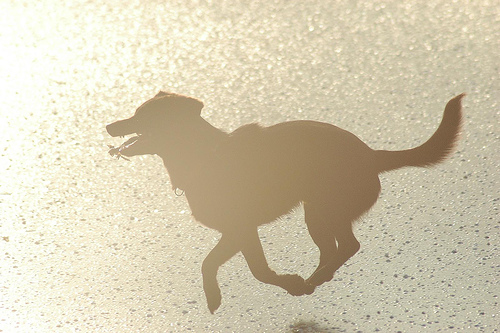<image>
Is the dog on the ground? No. The dog is not positioned on the ground. They may be near each other, but the dog is not supported by or resting on top of the ground. 